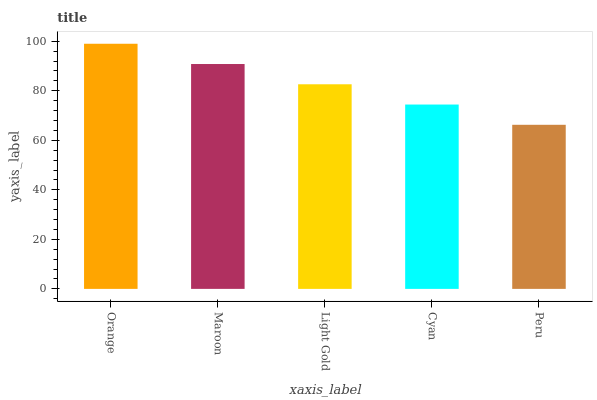Is Peru the minimum?
Answer yes or no. Yes. Is Orange the maximum?
Answer yes or no. Yes. Is Maroon the minimum?
Answer yes or no. No. Is Maroon the maximum?
Answer yes or no. No. Is Orange greater than Maroon?
Answer yes or no. Yes. Is Maroon less than Orange?
Answer yes or no. Yes. Is Maroon greater than Orange?
Answer yes or no. No. Is Orange less than Maroon?
Answer yes or no. No. Is Light Gold the high median?
Answer yes or no. Yes. Is Light Gold the low median?
Answer yes or no. Yes. Is Orange the high median?
Answer yes or no. No. Is Peru the low median?
Answer yes or no. No. 